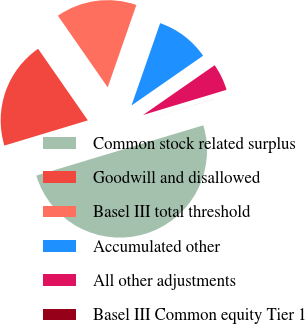Convert chart. <chart><loc_0><loc_0><loc_500><loc_500><pie_chart><fcel>Common stock related surplus<fcel>Goodwill and disallowed<fcel>Basel III total threshold<fcel>Accumulated other<fcel>All other adjustments<fcel>Basel III Common equity Tier 1<nl><fcel>49.98%<fcel>20.0%<fcel>15.0%<fcel>10.0%<fcel>5.01%<fcel>0.01%<nl></chart> 